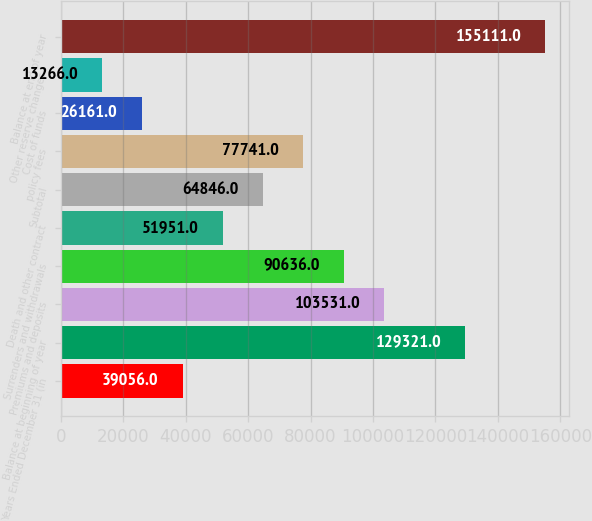Convert chart to OTSL. <chart><loc_0><loc_0><loc_500><loc_500><bar_chart><fcel>Years Ended December 31 (in<fcel>Balance at beginning of year<fcel>Premiums and deposits<fcel>Surrenders and withdrawals<fcel>Death and other contract<fcel>Subtotal<fcel>policy fees<fcel>Cost of funds<fcel>Other reserve changes<fcel>Balance at end of year<nl><fcel>39056<fcel>129321<fcel>103531<fcel>90636<fcel>51951<fcel>64846<fcel>77741<fcel>26161<fcel>13266<fcel>155111<nl></chart> 